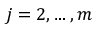<formula> <loc_0><loc_0><loc_500><loc_500>j = 2 , \dots , m</formula> 